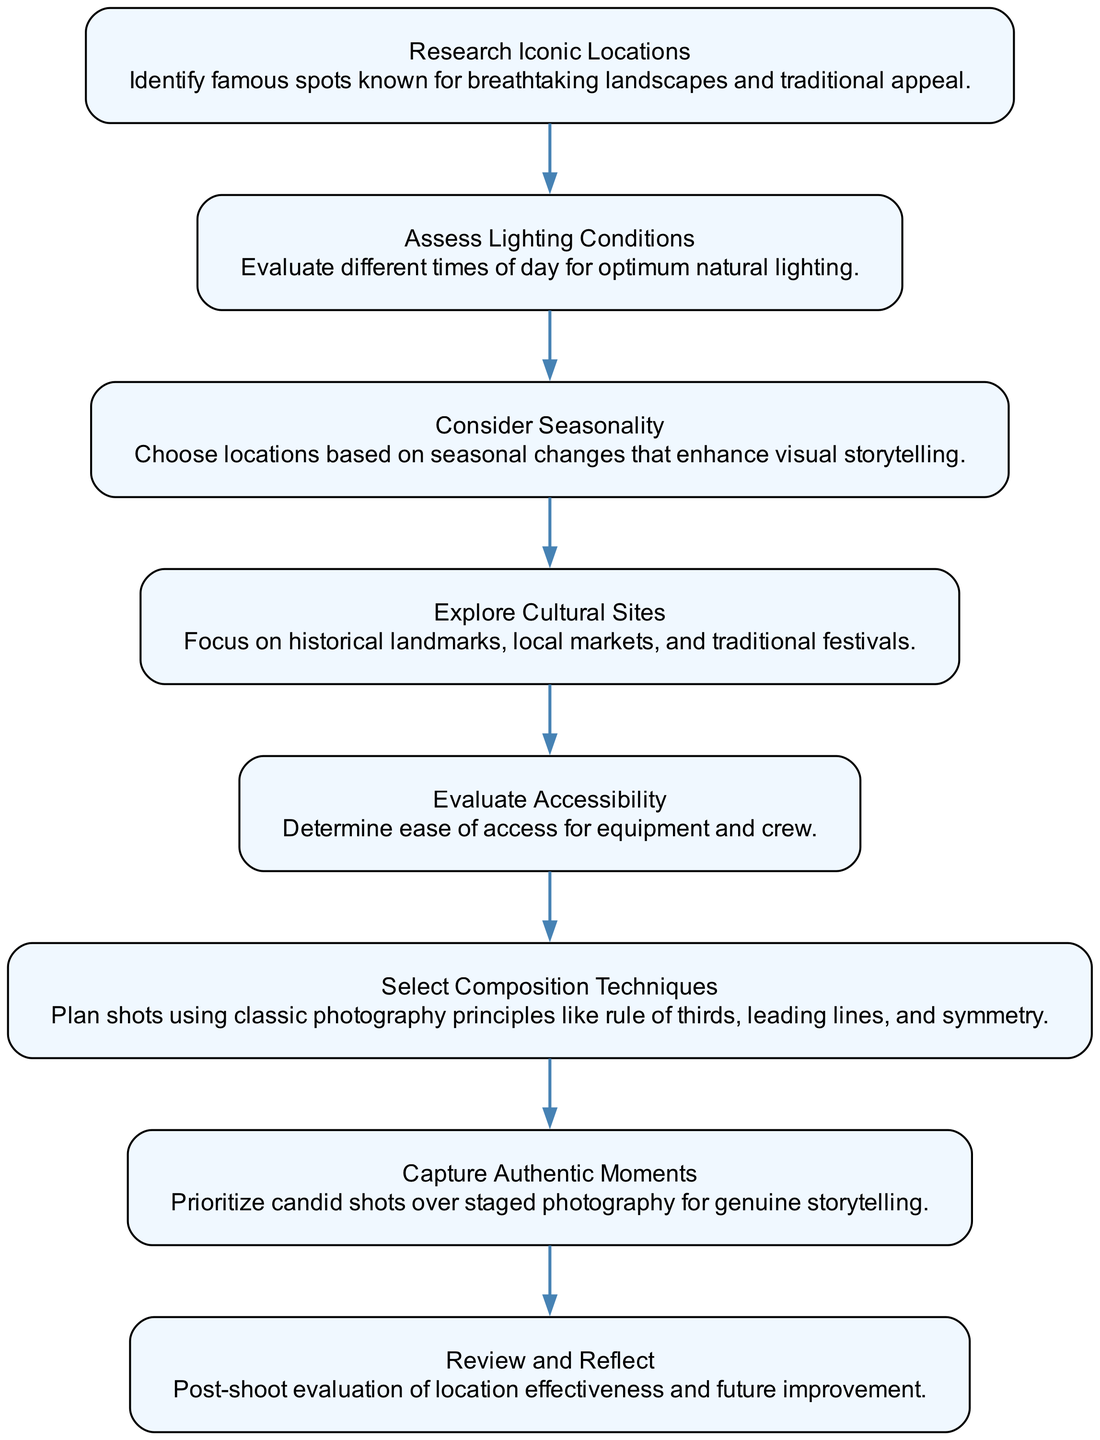What is the first step in selecting shooting locations? The first step is to "Research Iconic Locations," as indicated by the starting node of the flow chart. This step involves identifying famous spots known for breathtaking landscapes and traditional appeal.
Answer: Research Iconic Locations How many nodes are in the flow chart? By counting the unique steps in the flow chart, we can see there are a total of eight nodes that represent various actions in the location selection process.
Answer: 8 What is the primary focus of the node titled "Explore Cultural Sites"? The primary focus of this node is on historical landmarks, local markets, and traditional festivals, as stated in the detailed description of this step in the flow chart.
Answer: Historical landmarks, local markets, and traditional festivals Which node follows "Assess Lighting Conditions"? Following "Assess Lighting Conditions," the next node in the flow chart is "Consider Seasonality," which indicates a progression from evaluating lighting to considering seasonal effects on a location's visual appeal.
Answer: Consider Seasonality How does "Capture Authentic Moments" relate to the previous node? "Capture Authentic Moments" emphasizes shifting focus from staged photography to prioritizing candid shots, which follows "Select Composition Techniques," making it a subsequent action that enhances storytelling through genuine captures.
Answer: It shifts focus to candid shots for genuine storytelling What should be evaluated in the "Review and Reflect" step? In the "Review and Reflect" step, one should evaluate the effectiveness of the chosen locations in the shoot and identify areas for future improvement, as referenced in the description of this final step.
Answer: Effectiveness of location and future improvement Which step emphasizes planning shots using classic photography principles? The step that emphasizes planning shots using classic photography principles is "Select Composition Techniques." This step includes applying principles like the rule of thirds, leading lines, and symmetry in photography.
Answer: Select Composition Techniques What is the fourth step in the flow chart? The fourth step in the flow chart is "Explore Cultural Sites," which is focused on capturing footage at locations rich in culture and history.
Answer: Explore Cultural Sites 